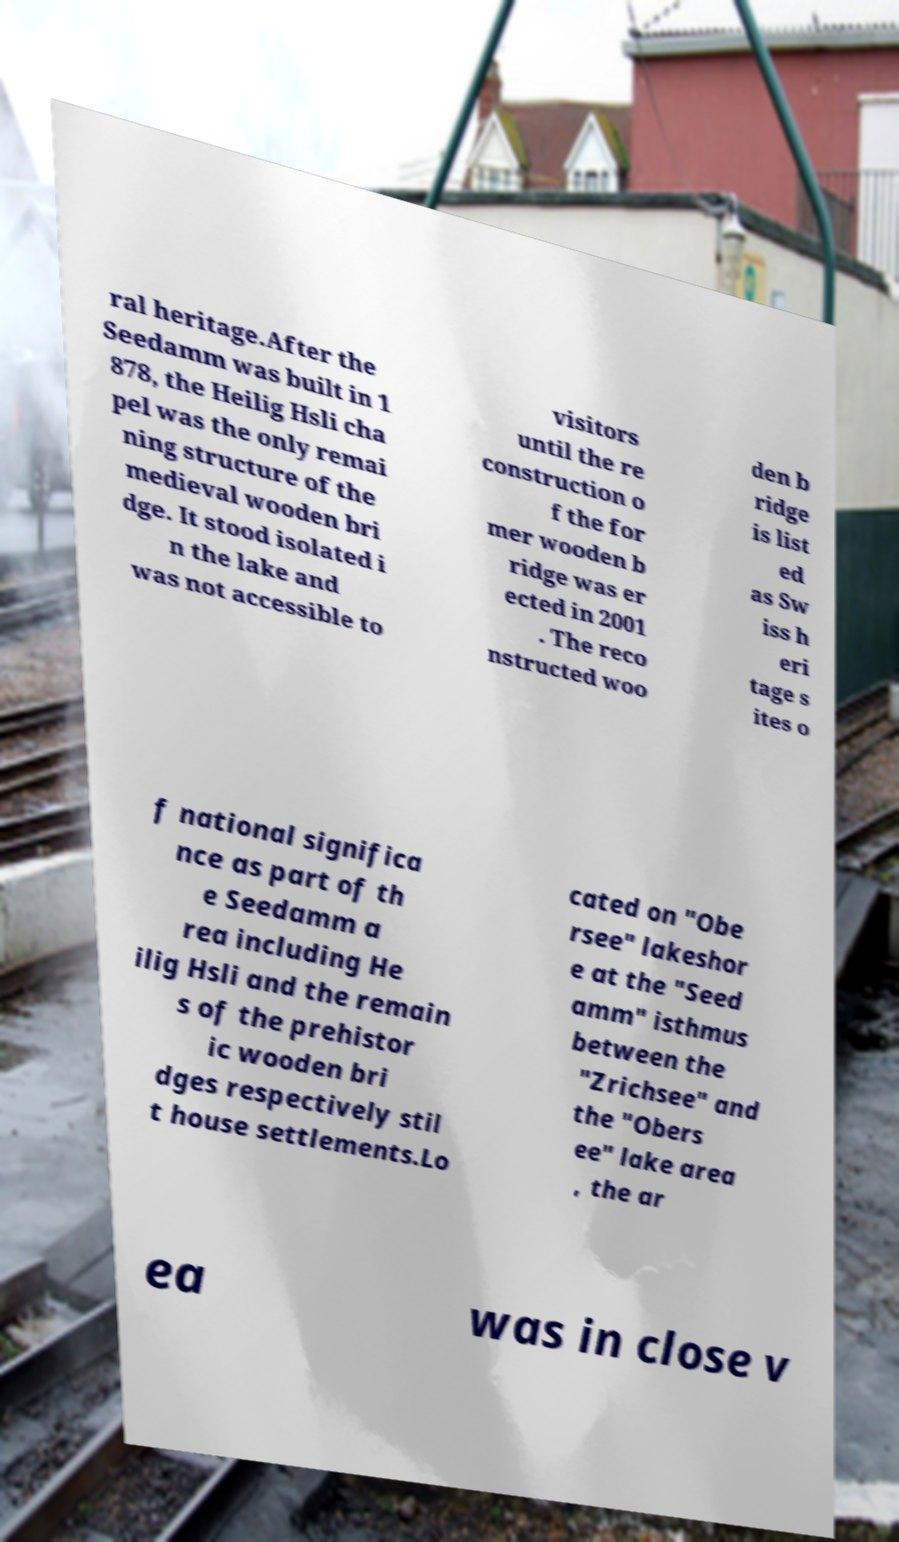What messages or text are displayed in this image? I need them in a readable, typed format. ral heritage.After the Seedamm was built in 1 878, the Heilig Hsli cha pel was the only remai ning structure of the medieval wooden bri dge. It stood isolated i n the lake and was not accessible to visitors until the re construction o f the for mer wooden b ridge was er ected in 2001 . The reco nstructed woo den b ridge is list ed as Sw iss h eri tage s ites o f national significa nce as part of th e Seedamm a rea including He ilig Hsli and the remain s of the prehistor ic wooden bri dges respectively stil t house settlements.Lo cated on "Obe rsee" lakeshor e at the "Seed amm" isthmus between the "Zrichsee" and the "Obers ee" lake area , the ar ea was in close v 